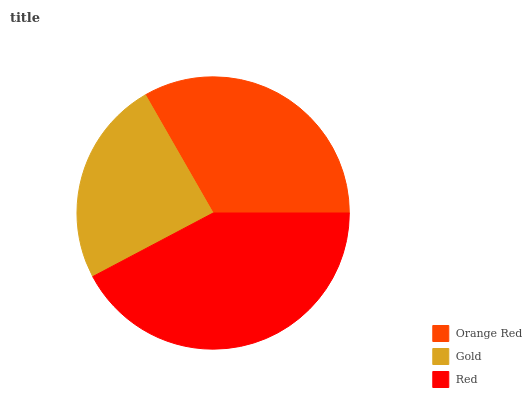Is Gold the minimum?
Answer yes or no. Yes. Is Red the maximum?
Answer yes or no. Yes. Is Red the minimum?
Answer yes or no. No. Is Gold the maximum?
Answer yes or no. No. Is Red greater than Gold?
Answer yes or no. Yes. Is Gold less than Red?
Answer yes or no. Yes. Is Gold greater than Red?
Answer yes or no. No. Is Red less than Gold?
Answer yes or no. No. Is Orange Red the high median?
Answer yes or no. Yes. Is Orange Red the low median?
Answer yes or no. Yes. Is Gold the high median?
Answer yes or no. No. Is Gold the low median?
Answer yes or no. No. 